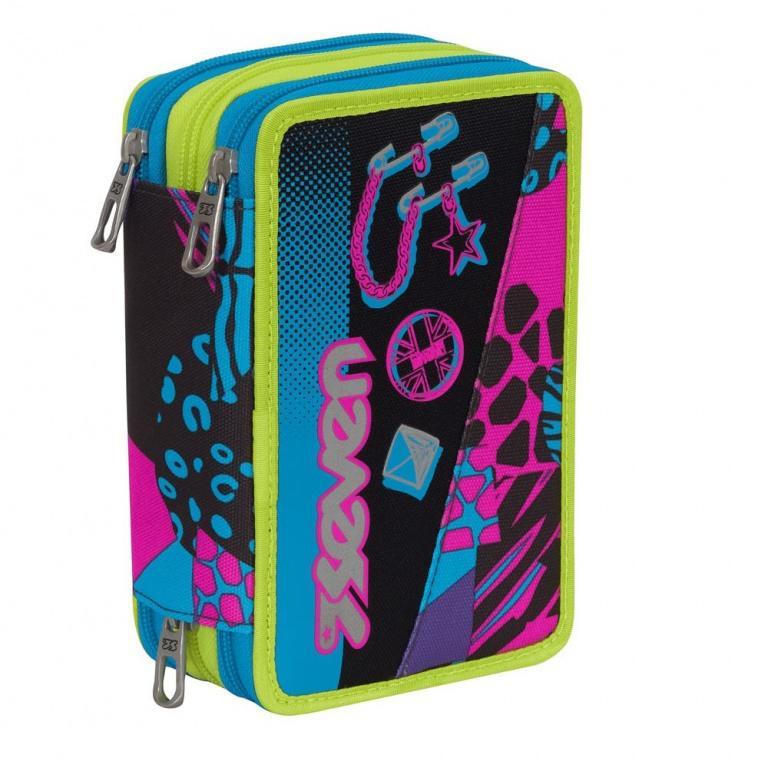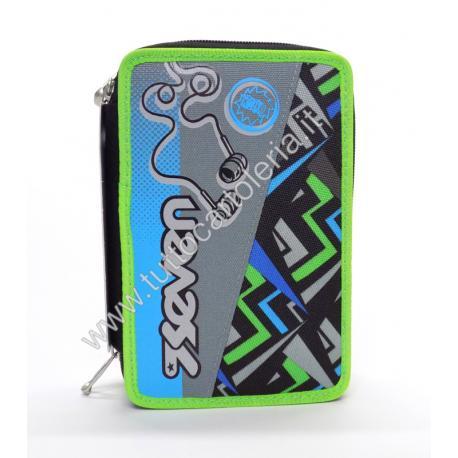The first image is the image on the left, the second image is the image on the right. Analyze the images presented: Is the assertion "The brand logo is visible on the outside of both pouches." valid? Answer yes or no. Yes. The first image is the image on the left, the second image is the image on the right. Assess this claim about the two images: "the left image shows two zippers on the pencil pouch top". Correct or not? Answer yes or no. Yes. 